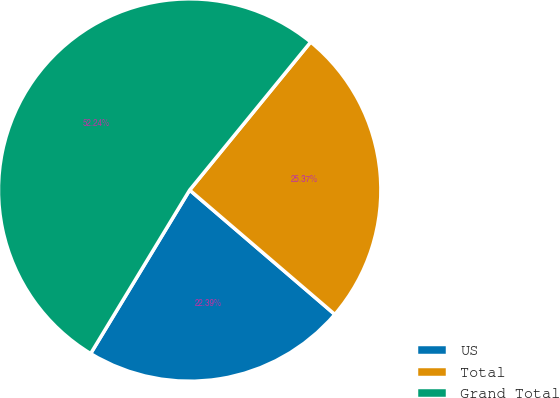Convert chart to OTSL. <chart><loc_0><loc_0><loc_500><loc_500><pie_chart><fcel>US<fcel>Total<fcel>Grand Total<nl><fcel>22.39%<fcel>25.37%<fcel>52.24%<nl></chart> 